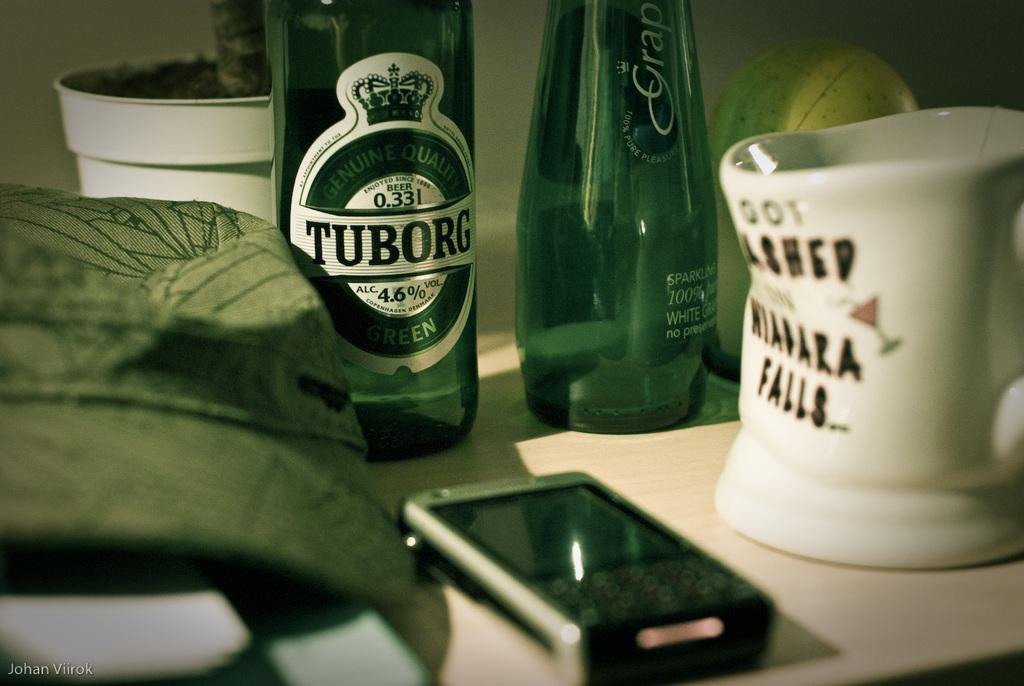<image>
Describe the image concisely. A bottle of Tuborg says it has 4.6 percent alcohol by volume. 